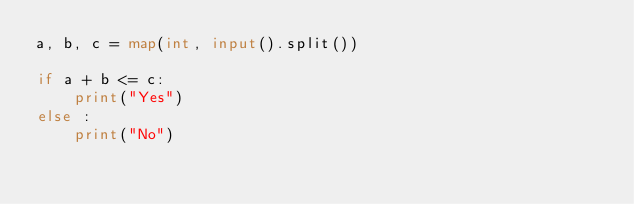Convert code to text. <code><loc_0><loc_0><loc_500><loc_500><_Python_>a, b, c = map(int, input().split())

if a + b <= c:
    print("Yes")
else :
    print("No")</code> 